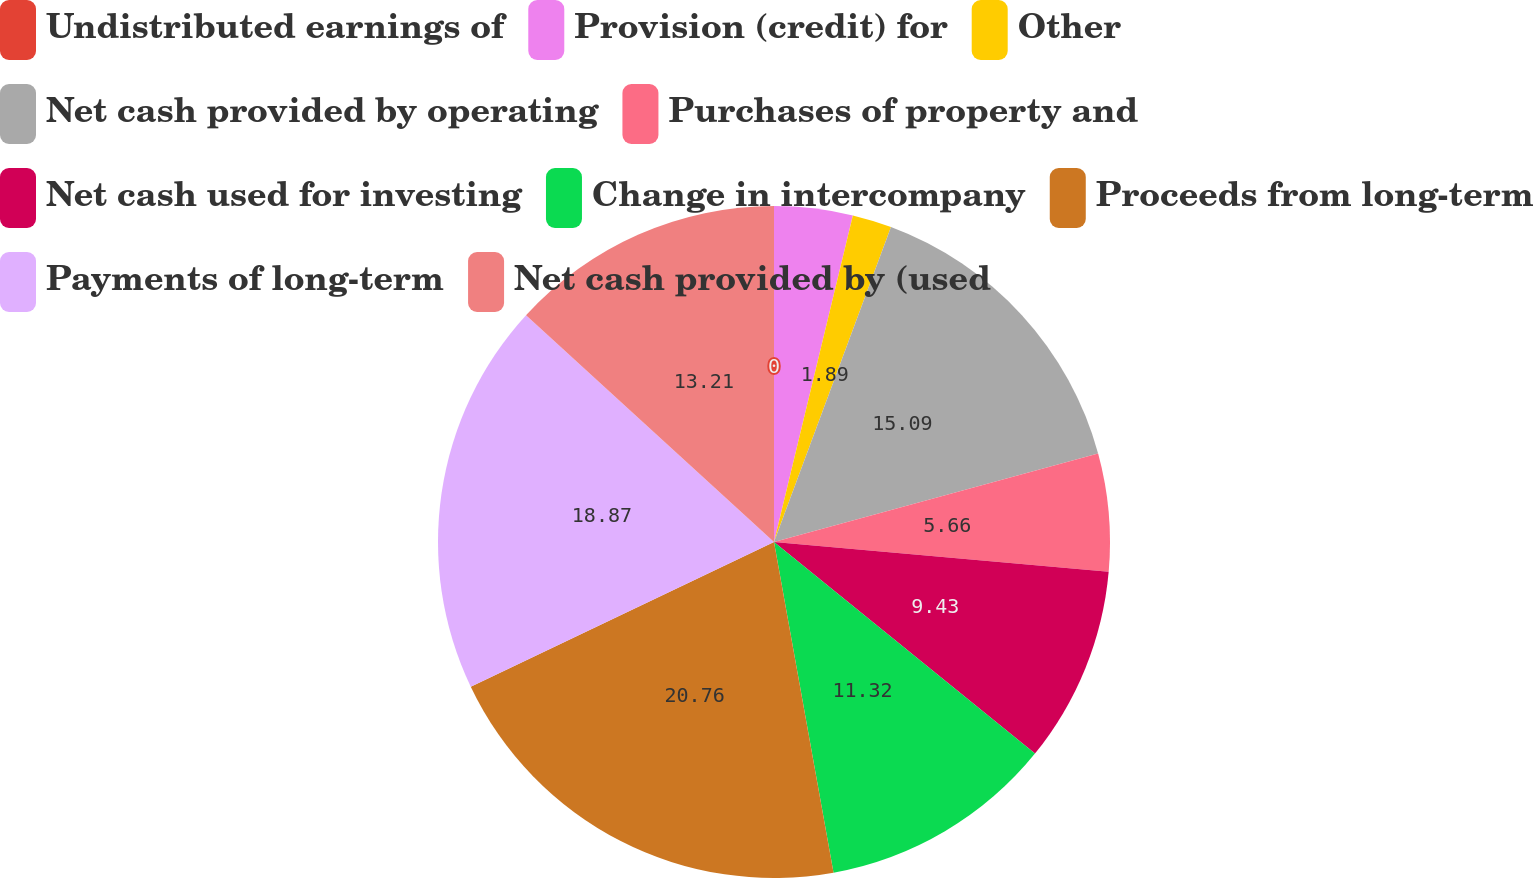<chart> <loc_0><loc_0><loc_500><loc_500><pie_chart><fcel>Undistributed earnings of<fcel>Provision (credit) for<fcel>Other<fcel>Net cash provided by operating<fcel>Purchases of property and<fcel>Net cash used for investing<fcel>Change in intercompany<fcel>Proceeds from long-term<fcel>Payments of long-term<fcel>Net cash provided by (used<nl><fcel>0.0%<fcel>3.77%<fcel>1.89%<fcel>15.09%<fcel>5.66%<fcel>9.43%<fcel>11.32%<fcel>20.75%<fcel>18.87%<fcel>13.21%<nl></chart> 